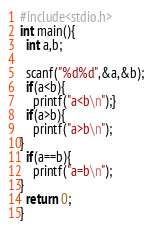Convert code to text. <code><loc_0><loc_0><loc_500><loc_500><_C_>#include<stdio.h>
int main(){
  int a,b;

  scanf("%d%d",&a,&b);
  if(a<b){
    printf("a<b\n");}
  if(a>b){
    printf("a>b\n");
}
  if(a==b){
    printf("a=b\n");
}
  return 0;
}</code> 